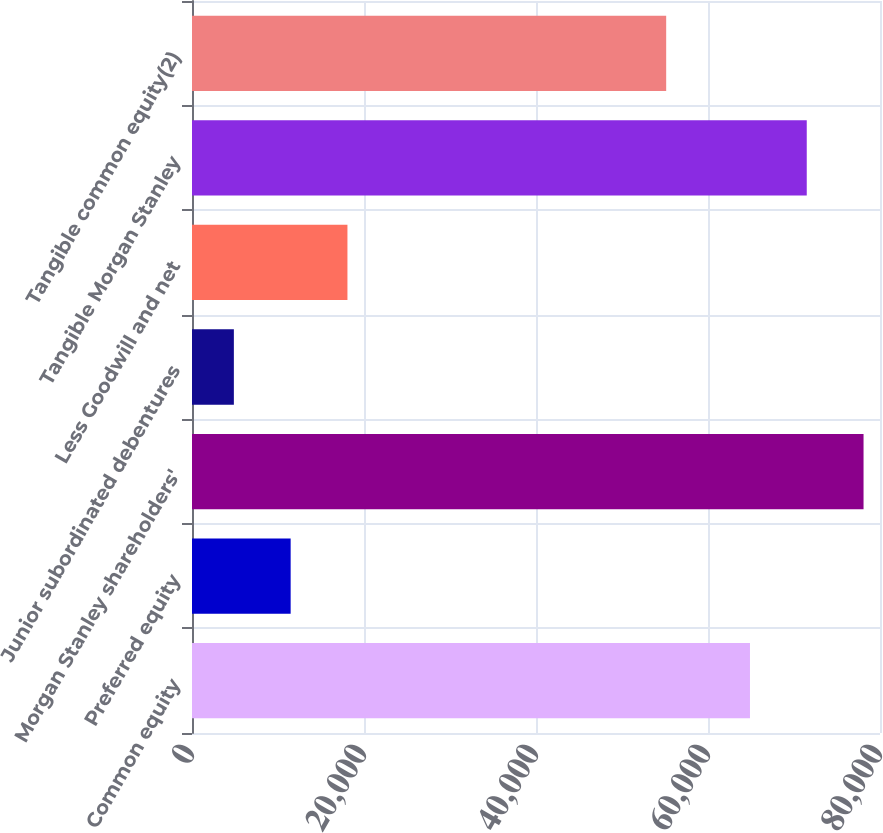Convert chart. <chart><loc_0><loc_0><loc_500><loc_500><bar_chart><fcel>Common equity<fcel>Preferred equity<fcel>Morgan Stanley shareholders'<fcel>Junior subordinated debentures<fcel>Less Goodwill and net<fcel>Tangible Morgan Stanley<fcel>Tangible common equity(2)<nl><fcel>64880<fcel>11471.2<fcel>78086.4<fcel>4868<fcel>18074.4<fcel>71483.2<fcel>55138<nl></chart> 